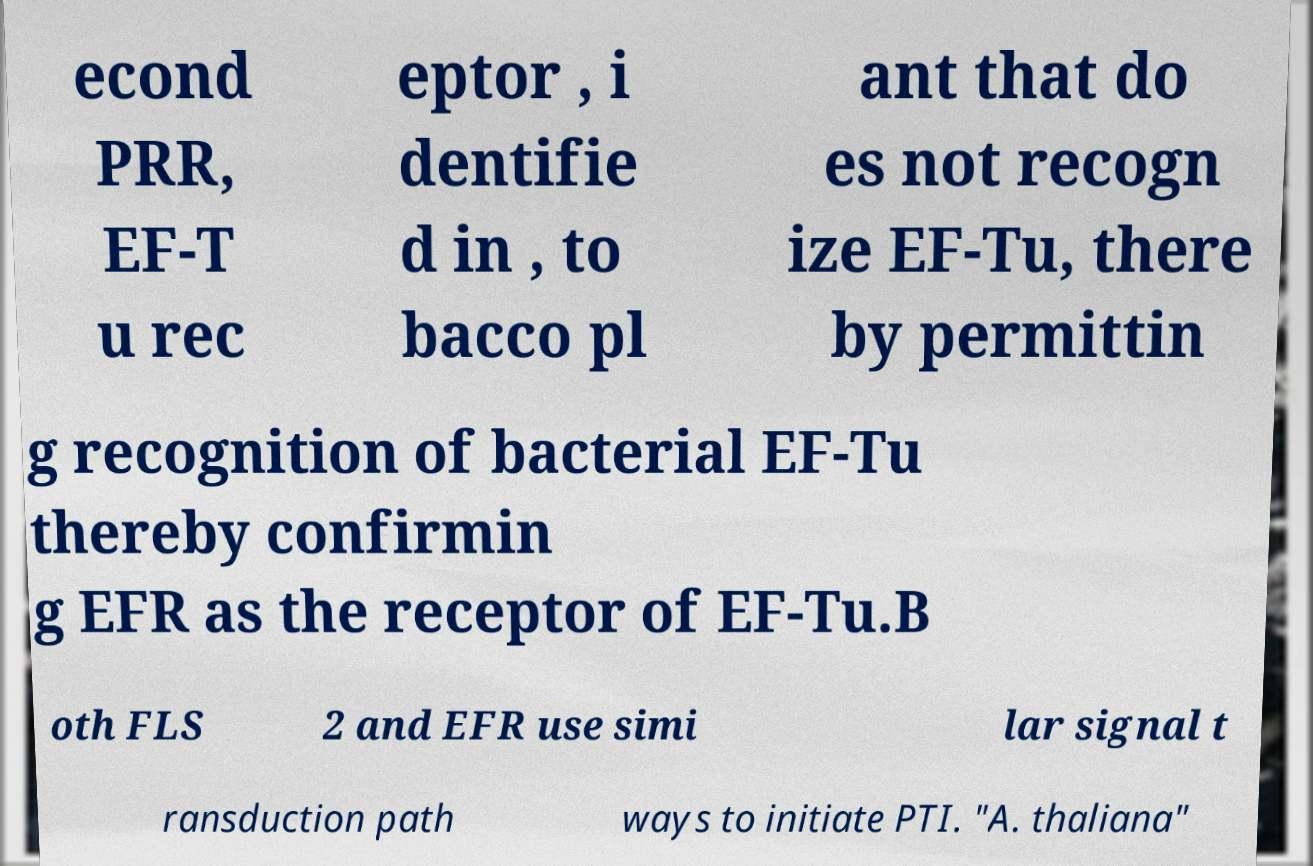Please read and relay the text visible in this image. What does it say? econd PRR, EF-T u rec eptor , i dentifie d in , to bacco pl ant that do es not recogn ize EF-Tu, there by permittin g recognition of bacterial EF-Tu thereby confirmin g EFR as the receptor of EF-Tu.B oth FLS 2 and EFR use simi lar signal t ransduction path ways to initiate PTI. "A. thaliana" 